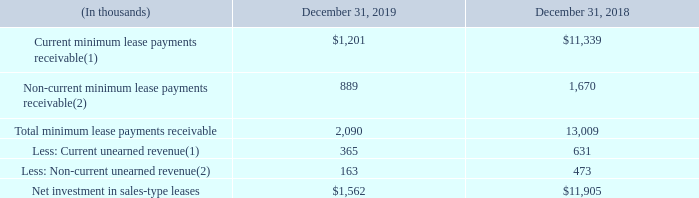Sales-Type Leases
We are the lessor in sales-type lease arrangements for network equipment, which have initial terms of up to five years. Our sales-type lease arrangements contain either a provision whereby the network equipment reverts back to us upon the expiration of the lease or a provision that allows the lessee to purchase the network equipment at a bargain purchase amount at the end of the lease. In addition, our sales-type lease arrangements do not contain any residual value guarantees or material restrictive covenants. The allocation of the consideration between lease and nonlease components is determined by stand-alone selling price by component. The net investment in sales-type leases consists of lease receivables less unearned income. Collectability of sales-type leases is evaluated periodically at an individual customer level. The Company has elected to exclude taxes related to sales-type leases from revenue and the associated expense of such taxes. As of December 31, 2019 and 2018, we did not have an allowance for credit losses for our net investment in sales-type leases. As of December 31, 2019 and 2018, the components of the net investment in sales-type leases were as follows:
(1) Included in other receivables on the Consolidated Balance Sheet.
(2) Included in other assets on the Consolidated Balance Sheet.
Where was current minimum lease payments receivable included in the Consolidated Balance Sheet? Other receivables. Where was non-current minimum lease payments receivable included in the Consolidated Balance Sheet? Other assets. What was the non-current minimum lease payments receivable in 2019?
Answer scale should be: thousand. $1,201. What was the difference in total minimum lease payments receivables between 2018 and 2019?
Answer scale should be: thousand. 2,090-13,009
Answer: -10919. What was the change in Non-current minimum lease payments receivable between 2018 and 2019?
Answer scale should be: thousand. 889-1,670
Answer: -781. What was the percentage change in net investment in sales-type leases between 2018 and 2019?
Answer scale should be: percent. ($1,562-$11,905)/$11,905
Answer: -86.88. 